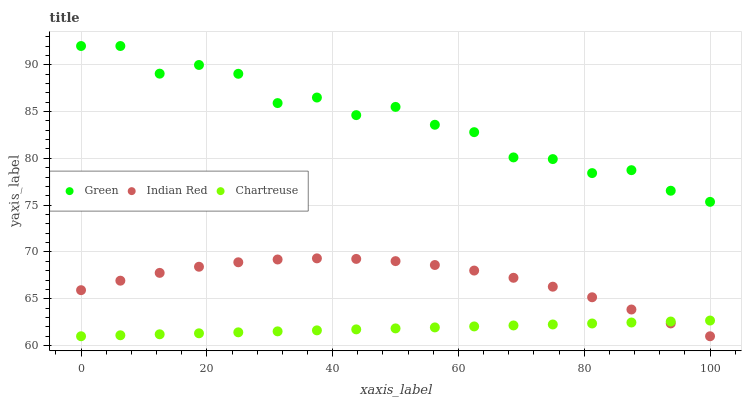Does Chartreuse have the minimum area under the curve?
Answer yes or no. Yes. Does Green have the maximum area under the curve?
Answer yes or no. Yes. Does Indian Red have the minimum area under the curve?
Answer yes or no. No. Does Indian Red have the maximum area under the curve?
Answer yes or no. No. Is Chartreuse the smoothest?
Answer yes or no. Yes. Is Green the roughest?
Answer yes or no. Yes. Is Indian Red the smoothest?
Answer yes or no. No. Is Indian Red the roughest?
Answer yes or no. No. Does Chartreuse have the lowest value?
Answer yes or no. Yes. Does Green have the lowest value?
Answer yes or no. No. Does Green have the highest value?
Answer yes or no. Yes. Does Indian Red have the highest value?
Answer yes or no. No. Is Indian Red less than Green?
Answer yes or no. Yes. Is Green greater than Indian Red?
Answer yes or no. Yes. Does Indian Red intersect Chartreuse?
Answer yes or no. Yes. Is Indian Red less than Chartreuse?
Answer yes or no. No. Is Indian Red greater than Chartreuse?
Answer yes or no. No. Does Indian Red intersect Green?
Answer yes or no. No. 